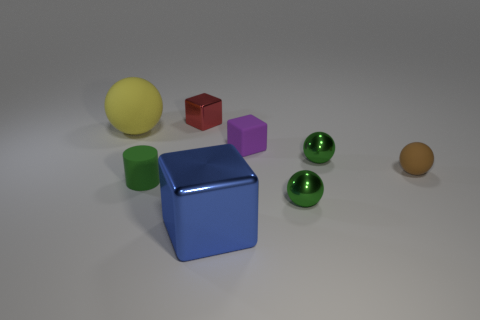How many gray objects are large matte cylinders or blocks?
Your answer should be very brief. 0. What color is the rubber cube?
Make the answer very short. Purple. Is the brown rubber object the same size as the yellow ball?
Ensure brevity in your answer.  No. Is there anything else that has the same shape as the big blue shiny object?
Your answer should be very brief. Yes. Does the purple cube have the same material as the cube left of the blue cube?
Offer a very short reply. No. There is a metallic cube that is in front of the matte block; does it have the same color as the matte cylinder?
Give a very brief answer. No. What number of small cubes are on the right side of the big blue block and behind the large rubber sphere?
Give a very brief answer. 0. What number of other objects are the same material as the green cylinder?
Give a very brief answer. 3. Are the green ball that is in front of the small green matte cylinder and the big blue thing made of the same material?
Your answer should be compact. Yes. There is a matte thing in front of the rubber thing to the right of the small green metallic ball behind the brown matte sphere; what size is it?
Provide a succinct answer. Small. 